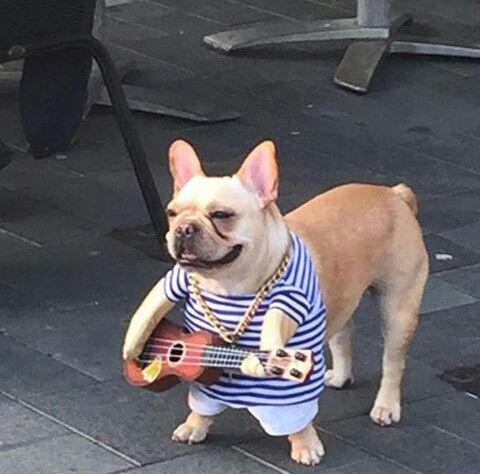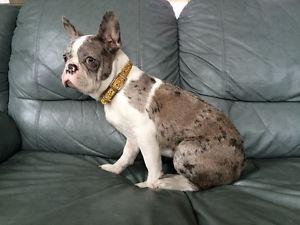The first image is the image on the left, the second image is the image on the right. Analyze the images presented: Is the assertion "Two dogs are posing together in the image on the left." valid? Answer yes or no. No. The first image is the image on the left, the second image is the image on the right. Given the left and right images, does the statement "The left image includes exactly twice as many dogs as the right image." hold true? Answer yes or no. No. 